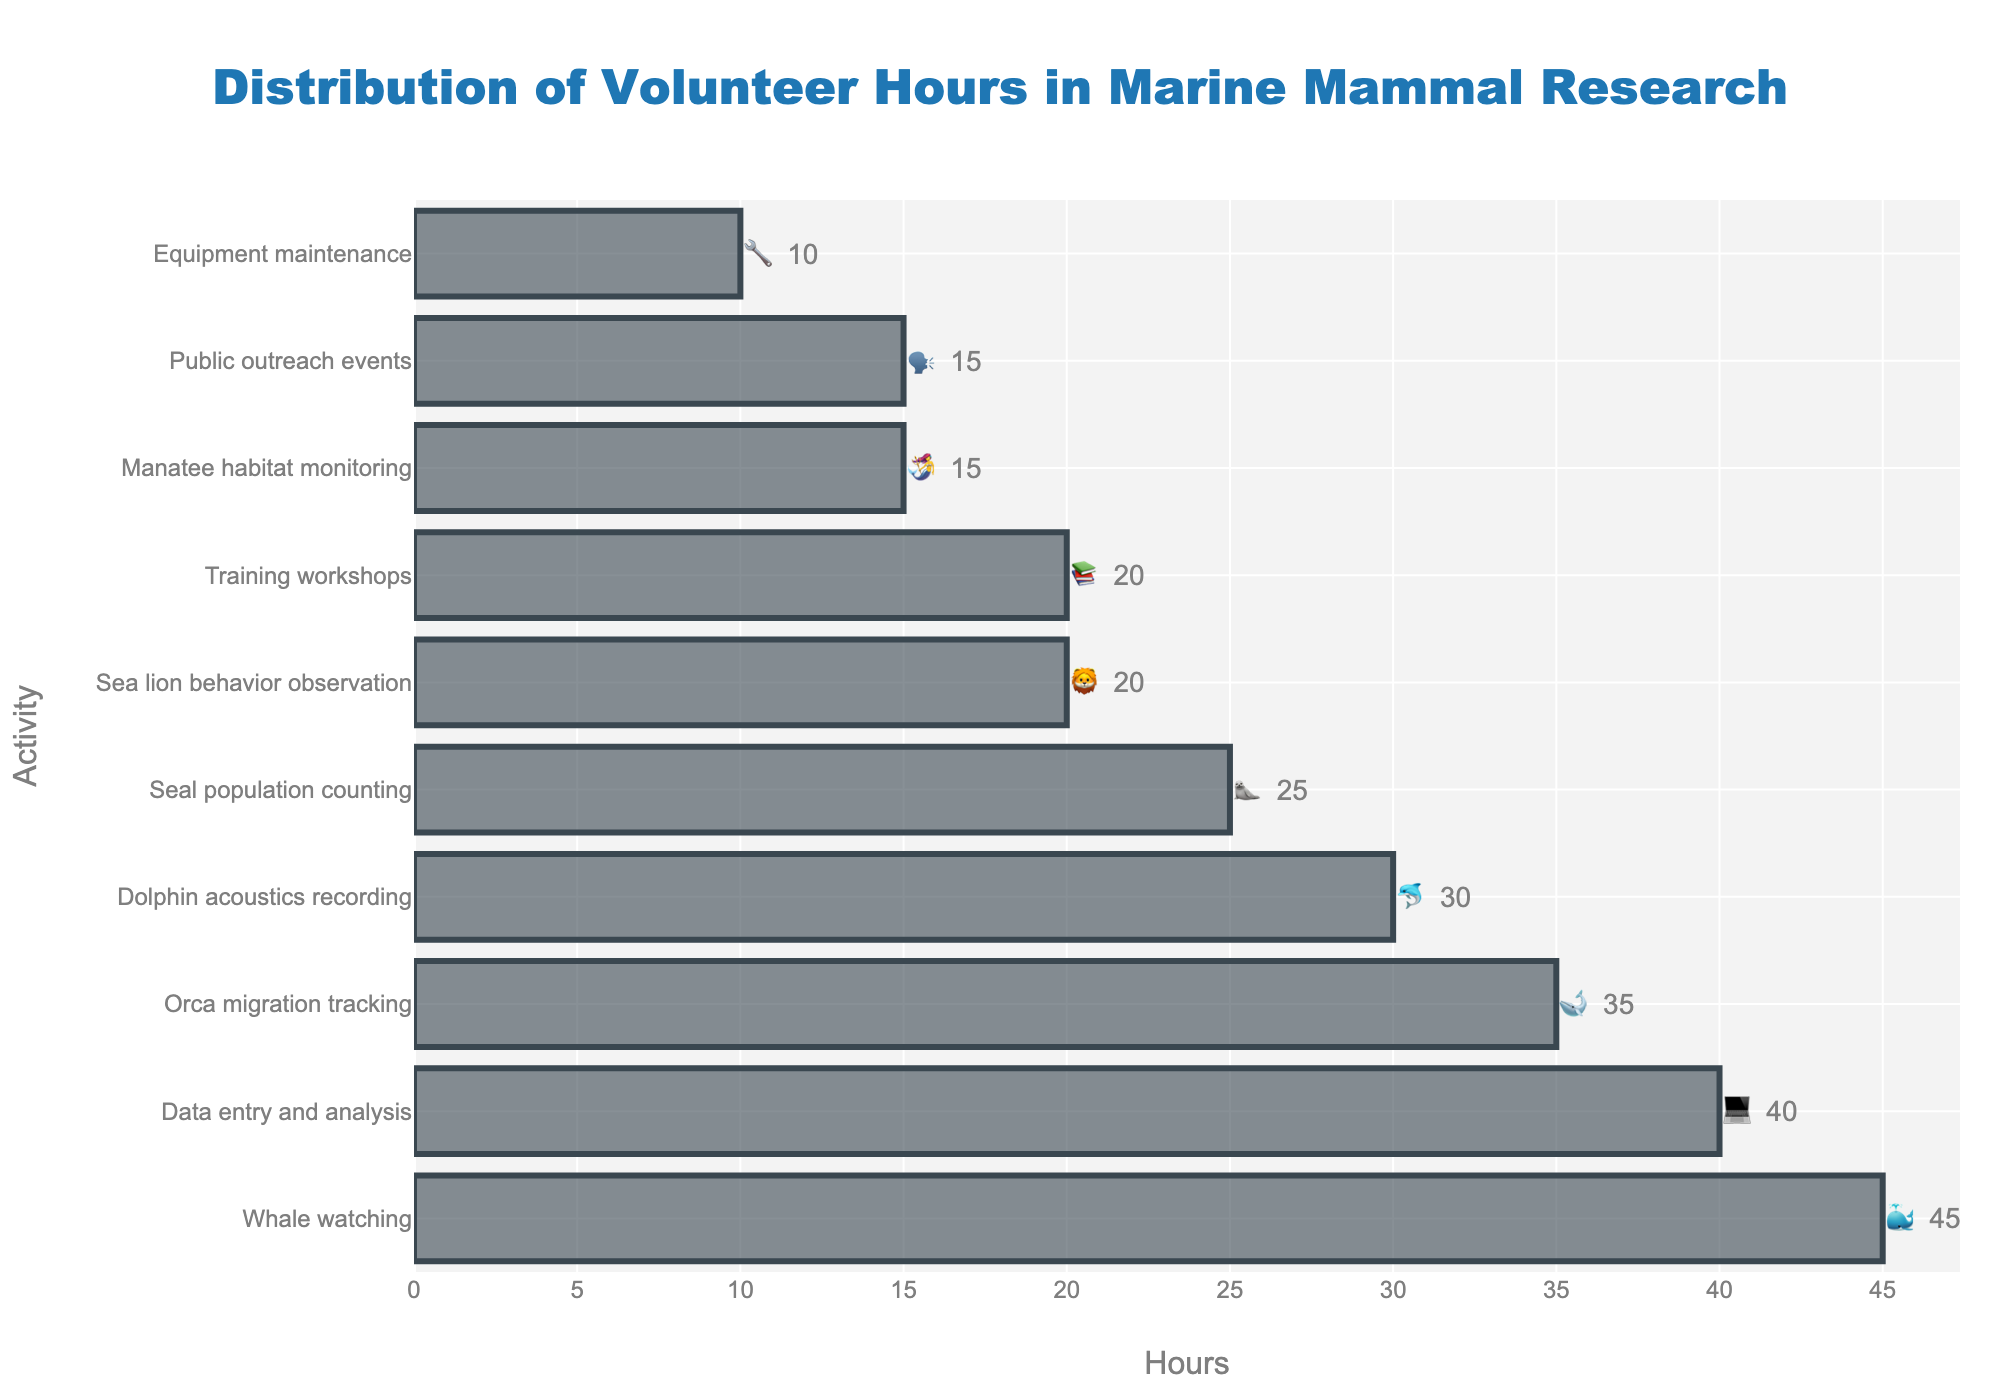What's the activity with the highest volunteer hours spent? The bar representing whale watching 🐳 has the highest number of hours, as it reaches the farthest point on the horizontal axis.
Answer: Whale watching 🐳 Which two activities have the same number of volunteer hours? The bars for sea lion behavior observation 🦁 and training workshops 📚 are at the same level, indicating they both have the same number of hours.
Answer: Sea lion behavior observation 🦁 and training workshops 📚 What's the total number of hours spent on dolphin acoustics recording 🐬 and orca migration tracking 🐋? The chart shows 30 hours for dolphin acoustics recording 🐬 and 35 hours for orca migration tracking 🐋. Adding these gives 30 + 35 = 65 hours.
Answer: 65 hours Compare the volunteer hours spent on data entry and analysis 💻 versus manatee habitat monitoring 🧜‍♀️. Which one is higher and by how much? Data entry and analysis 💻 has 40 hours, while manatee habitat monitoring 🧜‍♀️ has 15 hours. The difference is 40 - 15 = 25 hours.
Answer: Data entry and analysis 💻 by 25 hours If you combine the hours from the least volunteered activity with the hours from the most volunteered activity, what is the total? The least volunteered activity is equipment maintenance 🔧 with 10 hours, and the most volunteered activity is whale watching 🐳 with 45 hours. The total is 10 + 45 = 55 hours.
Answer: 55 hours 